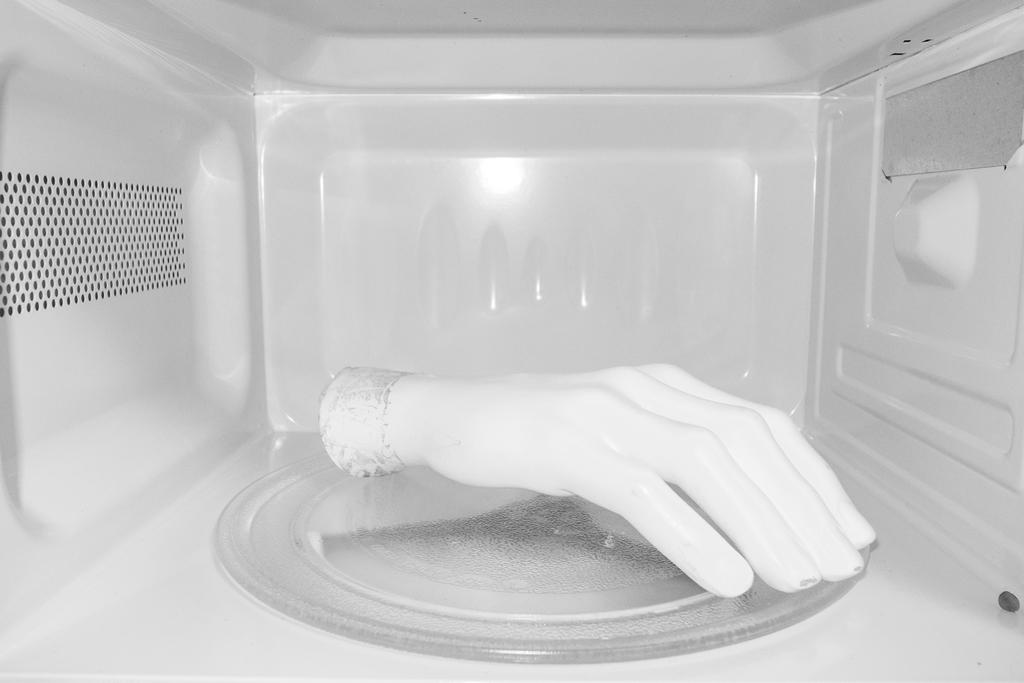What is the main subject of the image? The main subject of the image is a hand. Where is the hand located in the image? The hand is inside a microwave oven. What type of cover is placed on the shelf in the image? There is no cover or shelf present in the image; it only features a hand inside a microwave oven. 